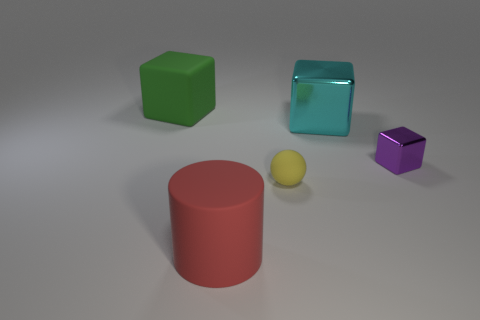There is a big thing that is on the left side of the yellow object and behind the big matte cylinder; what color is it? The color of the large object located on the left side of the small yellow sphere and behind the large matte red cylinder is green. This green object appears to be a cube, characterized by its distinct edges and uniform color. 